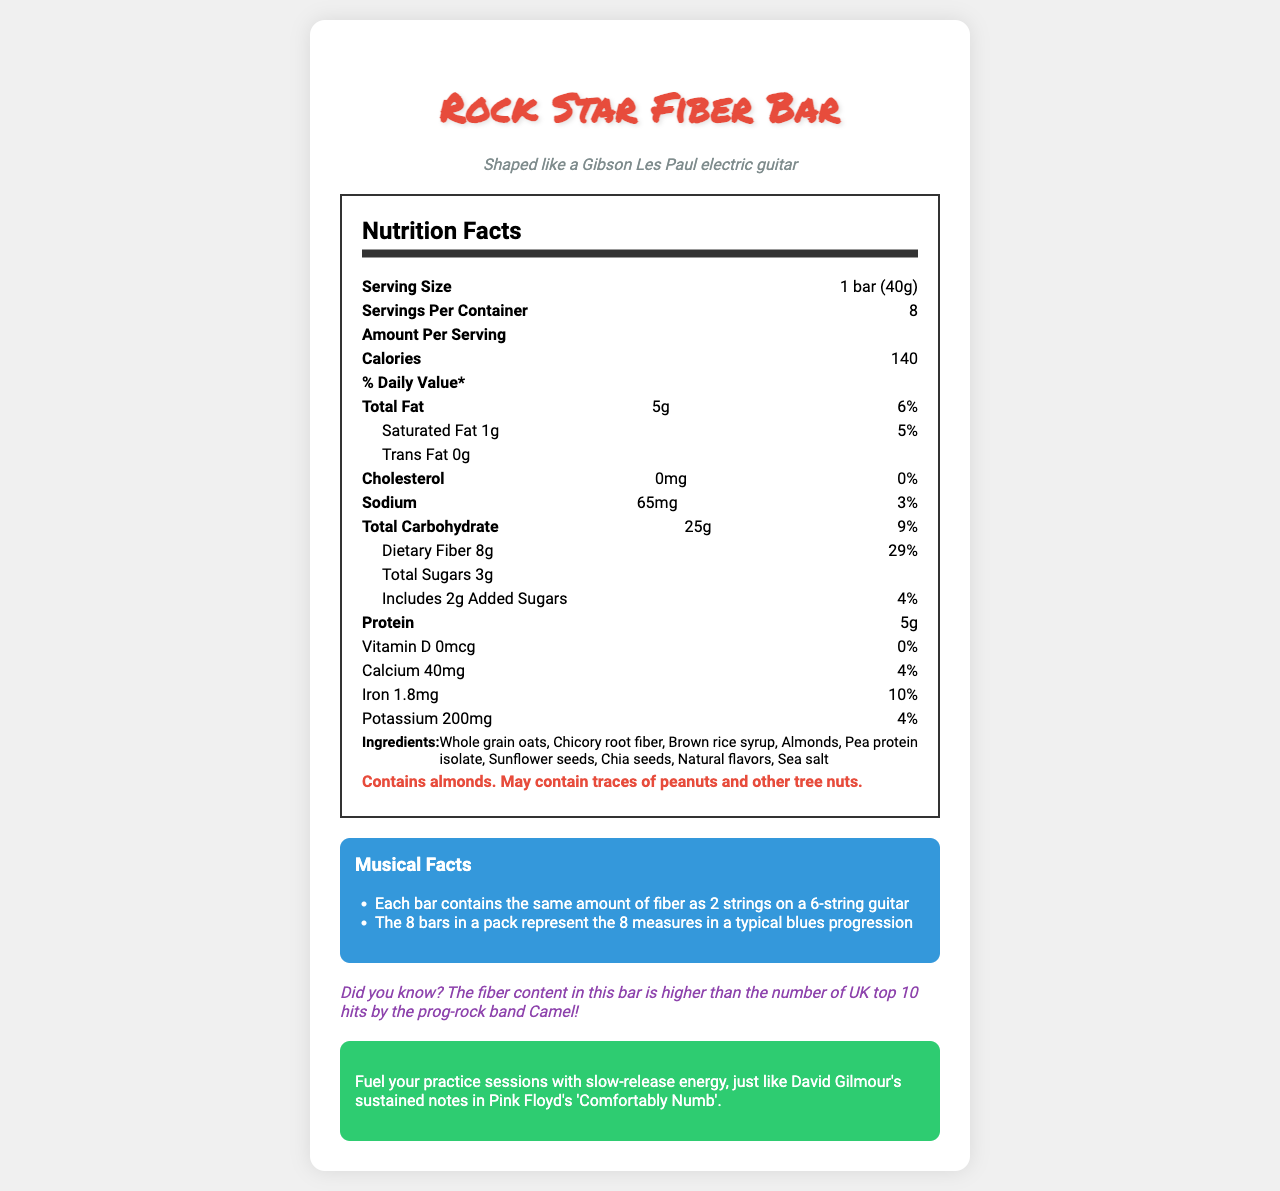what is the serving size of the Rock Star Fiber Bar? The serving size is explicitly mentioned in the Nutrition Facts section as "1 bar (40g)".
Answer: 1 bar (40g) how many calories are in one serving? The document lists the calories per serving as 140.
Answer: 140 how much dietary fiber is in each bar? The dietary fiber content is listed as 8g per serving.
Answer: 8g how many servings are in one container? The document states there are 8 servings per container.
Answer: 8 what is the total fat content including the daily value percentage? The total fat content is 5g which corresponds to 6% of the daily value.
Answer: 5g (6%) what is the shape of the Rock Star Fiber Bar? The document mentions that the bar is "Shaped like a Gibson Les Paul electric guitar".
Answer: Shaped like a Gibson Les Paul electric guitar which ingredient is the main source of fiber in the Rock Star Fiber Bar? A. Whole grain oats B. Chicory root fiber C. Almonds D. Pea protein isolate The list of ingredients includes "Chicory root fiber," which is known for its high fiber content.
Answer: B. Chicory root fiber what statement is true about the fiber content? A. The bars are low in fiber B. The bars have no dietary fiber C. Each bar has 8g of dietary fiber D. Fiber is not listed in the nutritional facts The nutritional facts clearly list 8g dietary fiber per serving.
Answer: C. Each bar has 8g of dietary fiber does the product contain any trans fat? The document lists trans fat as 0g.
Answer: No does the bar contain any cholesterol? The amount of cholesterol is listed as 0mg which means there is no cholesterol in the bar.
Answer: No summarize the main features of the Rock Star Fiber Bar document. The document provides nutritional details, ingredients, and intriguing musical trivia, highlighting the bar's health benefits and unique shape related to classic rock themes.
Answer: The Rock Star Fiber Bar is a low-sugar, high-fiber snack bar shaped like a Gibson Les Paul guitar. It provides 140 calories per serving with significant fiber (8g) and protein (5g). The bar contains healthy ingredients like whole grain oats, chicory root fiber, and almonds, while being low in added sugars and lacking trans fats and cholesterol. Additional information includes its allergen warning and interesting musical facts tying the bar to rock music themes. what is the total sugar content, including added sugars? The document lists total sugars as 3g and added sugars as 2g.
Answer: 3g total sugars with 2g added sugars which vitamins and minerals are included in the nutritional facts? The nutritional facts list Vitamin D (0mcg), Calcium (40mg), Iron (1.8mg), and Potassium (200mg).
Answer: Vitamin D, Calcium, Iron, Potassium is the bar suitable for someone with a peanut allergy? The allergen information states that the bar contains almonds and "may contain traces of peanuts and other tree nuts," thus it might not be suitable for someone with a peanut allergy.
Answer: Maybe how many milligrams of calcium does the bar provide? The document lists calcium as 40mg per serving.
Answer: 40mg the fiber content in the Rock Star Fiber Bar is compared to which UK top 10 hits? The document mentions that the fiber content is higher than the number of UK top 10 hits by the prog-rock band Camel, but does not specify the exact number.
Answer: Not enough information 